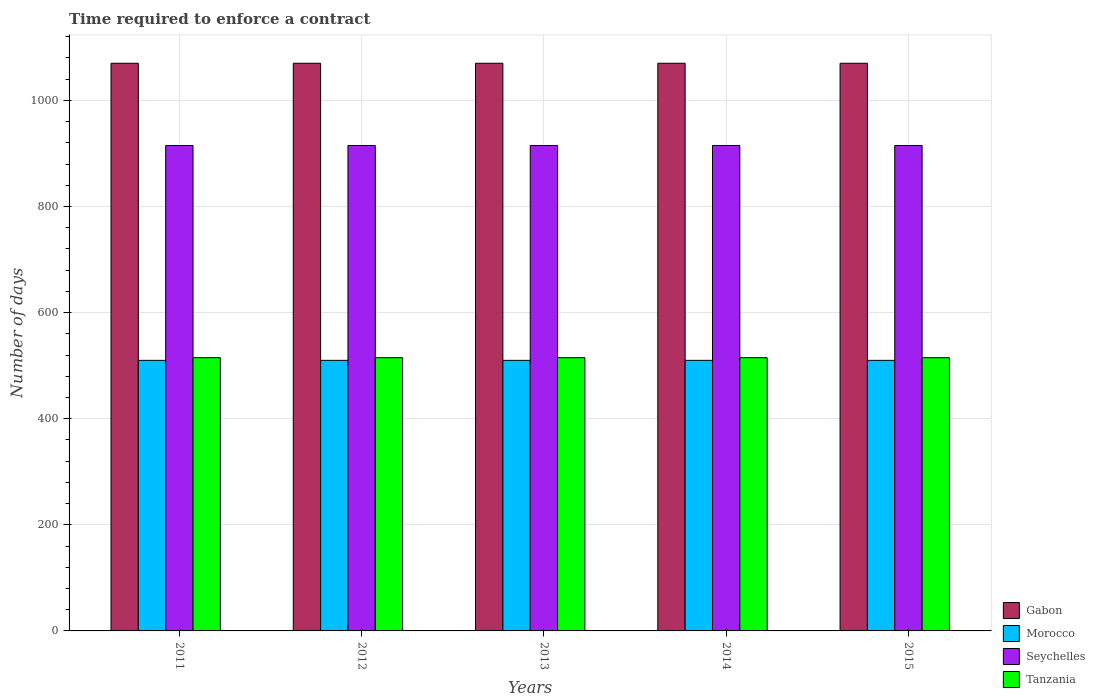How many groups of bars are there?
Make the answer very short. 5. Are the number of bars per tick equal to the number of legend labels?
Provide a succinct answer. Yes. How many bars are there on the 3rd tick from the left?
Ensure brevity in your answer.  4. How many bars are there on the 5th tick from the right?
Ensure brevity in your answer.  4. What is the label of the 1st group of bars from the left?
Your answer should be very brief. 2011. What is the number of days required to enforce a contract in Tanzania in 2013?
Give a very brief answer. 515. Across all years, what is the maximum number of days required to enforce a contract in Morocco?
Make the answer very short. 510. Across all years, what is the minimum number of days required to enforce a contract in Tanzania?
Offer a terse response. 515. In which year was the number of days required to enforce a contract in Morocco maximum?
Your response must be concise. 2011. In which year was the number of days required to enforce a contract in Seychelles minimum?
Give a very brief answer. 2011. What is the total number of days required to enforce a contract in Gabon in the graph?
Provide a short and direct response. 5350. What is the difference between the number of days required to enforce a contract in Tanzania in 2012 and that in 2013?
Your response must be concise. 0. What is the difference between the number of days required to enforce a contract in Gabon in 2011 and the number of days required to enforce a contract in Morocco in 2014?
Make the answer very short. 560. What is the average number of days required to enforce a contract in Morocco per year?
Make the answer very short. 510. In the year 2014, what is the difference between the number of days required to enforce a contract in Morocco and number of days required to enforce a contract in Tanzania?
Keep it short and to the point. -5. In how many years, is the number of days required to enforce a contract in Morocco greater than 840 days?
Your answer should be compact. 0. Is the number of days required to enforce a contract in Morocco in 2011 less than that in 2014?
Make the answer very short. No. Is the difference between the number of days required to enforce a contract in Morocco in 2011 and 2012 greater than the difference between the number of days required to enforce a contract in Tanzania in 2011 and 2012?
Keep it short and to the point. No. In how many years, is the number of days required to enforce a contract in Seychelles greater than the average number of days required to enforce a contract in Seychelles taken over all years?
Your answer should be compact. 0. Is the sum of the number of days required to enforce a contract in Tanzania in 2011 and 2013 greater than the maximum number of days required to enforce a contract in Seychelles across all years?
Make the answer very short. Yes. What does the 4th bar from the left in 2015 represents?
Provide a succinct answer. Tanzania. What does the 4th bar from the right in 2011 represents?
Make the answer very short. Gabon. Is it the case that in every year, the sum of the number of days required to enforce a contract in Morocco and number of days required to enforce a contract in Seychelles is greater than the number of days required to enforce a contract in Gabon?
Provide a short and direct response. Yes. How many bars are there?
Keep it short and to the point. 20. Are all the bars in the graph horizontal?
Your response must be concise. No. How many years are there in the graph?
Keep it short and to the point. 5. What is the difference between two consecutive major ticks on the Y-axis?
Your response must be concise. 200. Are the values on the major ticks of Y-axis written in scientific E-notation?
Your answer should be very brief. No. Does the graph contain grids?
Offer a very short reply. Yes. Where does the legend appear in the graph?
Provide a succinct answer. Bottom right. How are the legend labels stacked?
Offer a very short reply. Vertical. What is the title of the graph?
Keep it short and to the point. Time required to enforce a contract. Does "European Union" appear as one of the legend labels in the graph?
Ensure brevity in your answer.  No. What is the label or title of the Y-axis?
Your answer should be very brief. Number of days. What is the Number of days in Gabon in 2011?
Provide a succinct answer. 1070. What is the Number of days of Morocco in 2011?
Make the answer very short. 510. What is the Number of days of Seychelles in 2011?
Give a very brief answer. 915. What is the Number of days of Tanzania in 2011?
Your answer should be very brief. 515. What is the Number of days of Gabon in 2012?
Your answer should be compact. 1070. What is the Number of days of Morocco in 2012?
Make the answer very short. 510. What is the Number of days in Seychelles in 2012?
Keep it short and to the point. 915. What is the Number of days in Tanzania in 2012?
Your answer should be compact. 515. What is the Number of days of Gabon in 2013?
Offer a very short reply. 1070. What is the Number of days in Morocco in 2013?
Give a very brief answer. 510. What is the Number of days of Seychelles in 2013?
Keep it short and to the point. 915. What is the Number of days of Tanzania in 2013?
Ensure brevity in your answer.  515. What is the Number of days of Gabon in 2014?
Keep it short and to the point. 1070. What is the Number of days of Morocco in 2014?
Make the answer very short. 510. What is the Number of days in Seychelles in 2014?
Make the answer very short. 915. What is the Number of days in Tanzania in 2014?
Offer a terse response. 515. What is the Number of days of Gabon in 2015?
Provide a short and direct response. 1070. What is the Number of days of Morocco in 2015?
Offer a very short reply. 510. What is the Number of days of Seychelles in 2015?
Provide a succinct answer. 915. What is the Number of days of Tanzania in 2015?
Your response must be concise. 515. Across all years, what is the maximum Number of days in Gabon?
Keep it short and to the point. 1070. Across all years, what is the maximum Number of days of Morocco?
Provide a succinct answer. 510. Across all years, what is the maximum Number of days in Seychelles?
Your answer should be compact. 915. Across all years, what is the maximum Number of days in Tanzania?
Offer a terse response. 515. Across all years, what is the minimum Number of days in Gabon?
Provide a succinct answer. 1070. Across all years, what is the minimum Number of days of Morocco?
Offer a very short reply. 510. Across all years, what is the minimum Number of days in Seychelles?
Your answer should be very brief. 915. Across all years, what is the minimum Number of days of Tanzania?
Give a very brief answer. 515. What is the total Number of days of Gabon in the graph?
Keep it short and to the point. 5350. What is the total Number of days in Morocco in the graph?
Give a very brief answer. 2550. What is the total Number of days in Seychelles in the graph?
Provide a succinct answer. 4575. What is the total Number of days of Tanzania in the graph?
Offer a very short reply. 2575. What is the difference between the Number of days of Gabon in 2011 and that in 2012?
Keep it short and to the point. 0. What is the difference between the Number of days of Seychelles in 2011 and that in 2012?
Your answer should be compact. 0. What is the difference between the Number of days in Gabon in 2011 and that in 2013?
Provide a short and direct response. 0. What is the difference between the Number of days in Morocco in 2011 and that in 2013?
Your response must be concise. 0. What is the difference between the Number of days in Gabon in 2011 and that in 2014?
Your response must be concise. 0. What is the difference between the Number of days in Gabon in 2011 and that in 2015?
Provide a succinct answer. 0. What is the difference between the Number of days in Morocco in 2011 and that in 2015?
Your answer should be very brief. 0. What is the difference between the Number of days of Morocco in 2012 and that in 2013?
Make the answer very short. 0. What is the difference between the Number of days of Seychelles in 2012 and that in 2013?
Keep it short and to the point. 0. What is the difference between the Number of days of Seychelles in 2012 and that in 2014?
Ensure brevity in your answer.  0. What is the difference between the Number of days of Tanzania in 2012 and that in 2014?
Your answer should be very brief. 0. What is the difference between the Number of days of Tanzania in 2012 and that in 2015?
Provide a short and direct response. 0. What is the difference between the Number of days in Gabon in 2013 and that in 2014?
Your response must be concise. 0. What is the difference between the Number of days of Tanzania in 2013 and that in 2014?
Your response must be concise. 0. What is the difference between the Number of days of Gabon in 2013 and that in 2015?
Make the answer very short. 0. What is the difference between the Number of days of Morocco in 2013 and that in 2015?
Make the answer very short. 0. What is the difference between the Number of days in Seychelles in 2013 and that in 2015?
Ensure brevity in your answer.  0. What is the difference between the Number of days in Gabon in 2014 and that in 2015?
Provide a succinct answer. 0. What is the difference between the Number of days of Morocco in 2014 and that in 2015?
Your answer should be very brief. 0. What is the difference between the Number of days in Seychelles in 2014 and that in 2015?
Provide a short and direct response. 0. What is the difference between the Number of days of Tanzania in 2014 and that in 2015?
Offer a very short reply. 0. What is the difference between the Number of days of Gabon in 2011 and the Number of days of Morocco in 2012?
Offer a terse response. 560. What is the difference between the Number of days of Gabon in 2011 and the Number of days of Seychelles in 2012?
Give a very brief answer. 155. What is the difference between the Number of days in Gabon in 2011 and the Number of days in Tanzania in 2012?
Provide a short and direct response. 555. What is the difference between the Number of days of Morocco in 2011 and the Number of days of Seychelles in 2012?
Make the answer very short. -405. What is the difference between the Number of days in Gabon in 2011 and the Number of days in Morocco in 2013?
Provide a short and direct response. 560. What is the difference between the Number of days of Gabon in 2011 and the Number of days of Seychelles in 2013?
Make the answer very short. 155. What is the difference between the Number of days in Gabon in 2011 and the Number of days in Tanzania in 2013?
Ensure brevity in your answer.  555. What is the difference between the Number of days of Morocco in 2011 and the Number of days of Seychelles in 2013?
Give a very brief answer. -405. What is the difference between the Number of days in Gabon in 2011 and the Number of days in Morocco in 2014?
Provide a succinct answer. 560. What is the difference between the Number of days of Gabon in 2011 and the Number of days of Seychelles in 2014?
Your answer should be very brief. 155. What is the difference between the Number of days in Gabon in 2011 and the Number of days in Tanzania in 2014?
Provide a succinct answer. 555. What is the difference between the Number of days in Morocco in 2011 and the Number of days in Seychelles in 2014?
Provide a succinct answer. -405. What is the difference between the Number of days in Gabon in 2011 and the Number of days in Morocco in 2015?
Your answer should be compact. 560. What is the difference between the Number of days of Gabon in 2011 and the Number of days of Seychelles in 2015?
Offer a very short reply. 155. What is the difference between the Number of days in Gabon in 2011 and the Number of days in Tanzania in 2015?
Give a very brief answer. 555. What is the difference between the Number of days of Morocco in 2011 and the Number of days of Seychelles in 2015?
Your answer should be very brief. -405. What is the difference between the Number of days in Gabon in 2012 and the Number of days in Morocco in 2013?
Make the answer very short. 560. What is the difference between the Number of days in Gabon in 2012 and the Number of days in Seychelles in 2013?
Provide a short and direct response. 155. What is the difference between the Number of days of Gabon in 2012 and the Number of days of Tanzania in 2013?
Give a very brief answer. 555. What is the difference between the Number of days of Morocco in 2012 and the Number of days of Seychelles in 2013?
Provide a succinct answer. -405. What is the difference between the Number of days in Seychelles in 2012 and the Number of days in Tanzania in 2013?
Keep it short and to the point. 400. What is the difference between the Number of days of Gabon in 2012 and the Number of days of Morocco in 2014?
Provide a short and direct response. 560. What is the difference between the Number of days of Gabon in 2012 and the Number of days of Seychelles in 2014?
Offer a very short reply. 155. What is the difference between the Number of days of Gabon in 2012 and the Number of days of Tanzania in 2014?
Give a very brief answer. 555. What is the difference between the Number of days in Morocco in 2012 and the Number of days in Seychelles in 2014?
Provide a succinct answer. -405. What is the difference between the Number of days of Morocco in 2012 and the Number of days of Tanzania in 2014?
Provide a succinct answer. -5. What is the difference between the Number of days of Gabon in 2012 and the Number of days of Morocco in 2015?
Your response must be concise. 560. What is the difference between the Number of days of Gabon in 2012 and the Number of days of Seychelles in 2015?
Offer a very short reply. 155. What is the difference between the Number of days in Gabon in 2012 and the Number of days in Tanzania in 2015?
Give a very brief answer. 555. What is the difference between the Number of days in Morocco in 2012 and the Number of days in Seychelles in 2015?
Your response must be concise. -405. What is the difference between the Number of days in Morocco in 2012 and the Number of days in Tanzania in 2015?
Provide a succinct answer. -5. What is the difference between the Number of days of Seychelles in 2012 and the Number of days of Tanzania in 2015?
Provide a succinct answer. 400. What is the difference between the Number of days of Gabon in 2013 and the Number of days of Morocco in 2014?
Ensure brevity in your answer.  560. What is the difference between the Number of days in Gabon in 2013 and the Number of days in Seychelles in 2014?
Your answer should be very brief. 155. What is the difference between the Number of days of Gabon in 2013 and the Number of days of Tanzania in 2014?
Ensure brevity in your answer.  555. What is the difference between the Number of days of Morocco in 2013 and the Number of days of Seychelles in 2014?
Keep it short and to the point. -405. What is the difference between the Number of days of Morocco in 2013 and the Number of days of Tanzania in 2014?
Your answer should be compact. -5. What is the difference between the Number of days of Gabon in 2013 and the Number of days of Morocco in 2015?
Keep it short and to the point. 560. What is the difference between the Number of days of Gabon in 2013 and the Number of days of Seychelles in 2015?
Ensure brevity in your answer.  155. What is the difference between the Number of days of Gabon in 2013 and the Number of days of Tanzania in 2015?
Provide a short and direct response. 555. What is the difference between the Number of days in Morocco in 2013 and the Number of days in Seychelles in 2015?
Give a very brief answer. -405. What is the difference between the Number of days in Seychelles in 2013 and the Number of days in Tanzania in 2015?
Your answer should be compact. 400. What is the difference between the Number of days in Gabon in 2014 and the Number of days in Morocco in 2015?
Offer a terse response. 560. What is the difference between the Number of days in Gabon in 2014 and the Number of days in Seychelles in 2015?
Provide a succinct answer. 155. What is the difference between the Number of days in Gabon in 2014 and the Number of days in Tanzania in 2015?
Your response must be concise. 555. What is the difference between the Number of days in Morocco in 2014 and the Number of days in Seychelles in 2015?
Provide a succinct answer. -405. What is the difference between the Number of days of Seychelles in 2014 and the Number of days of Tanzania in 2015?
Your answer should be compact. 400. What is the average Number of days in Gabon per year?
Your answer should be very brief. 1070. What is the average Number of days of Morocco per year?
Your response must be concise. 510. What is the average Number of days in Seychelles per year?
Offer a very short reply. 915. What is the average Number of days in Tanzania per year?
Make the answer very short. 515. In the year 2011, what is the difference between the Number of days in Gabon and Number of days in Morocco?
Keep it short and to the point. 560. In the year 2011, what is the difference between the Number of days in Gabon and Number of days in Seychelles?
Provide a succinct answer. 155. In the year 2011, what is the difference between the Number of days in Gabon and Number of days in Tanzania?
Your response must be concise. 555. In the year 2011, what is the difference between the Number of days of Morocco and Number of days of Seychelles?
Provide a succinct answer. -405. In the year 2011, what is the difference between the Number of days in Morocco and Number of days in Tanzania?
Keep it short and to the point. -5. In the year 2011, what is the difference between the Number of days of Seychelles and Number of days of Tanzania?
Provide a succinct answer. 400. In the year 2012, what is the difference between the Number of days of Gabon and Number of days of Morocco?
Offer a terse response. 560. In the year 2012, what is the difference between the Number of days in Gabon and Number of days in Seychelles?
Make the answer very short. 155. In the year 2012, what is the difference between the Number of days in Gabon and Number of days in Tanzania?
Keep it short and to the point. 555. In the year 2012, what is the difference between the Number of days in Morocco and Number of days in Seychelles?
Ensure brevity in your answer.  -405. In the year 2012, what is the difference between the Number of days in Seychelles and Number of days in Tanzania?
Your answer should be very brief. 400. In the year 2013, what is the difference between the Number of days of Gabon and Number of days of Morocco?
Provide a short and direct response. 560. In the year 2013, what is the difference between the Number of days of Gabon and Number of days of Seychelles?
Keep it short and to the point. 155. In the year 2013, what is the difference between the Number of days in Gabon and Number of days in Tanzania?
Make the answer very short. 555. In the year 2013, what is the difference between the Number of days of Morocco and Number of days of Seychelles?
Give a very brief answer. -405. In the year 2014, what is the difference between the Number of days in Gabon and Number of days in Morocco?
Your response must be concise. 560. In the year 2014, what is the difference between the Number of days of Gabon and Number of days of Seychelles?
Your answer should be compact. 155. In the year 2014, what is the difference between the Number of days of Gabon and Number of days of Tanzania?
Offer a terse response. 555. In the year 2014, what is the difference between the Number of days in Morocco and Number of days in Seychelles?
Your response must be concise. -405. In the year 2015, what is the difference between the Number of days of Gabon and Number of days of Morocco?
Provide a short and direct response. 560. In the year 2015, what is the difference between the Number of days in Gabon and Number of days in Seychelles?
Make the answer very short. 155. In the year 2015, what is the difference between the Number of days in Gabon and Number of days in Tanzania?
Your answer should be compact. 555. In the year 2015, what is the difference between the Number of days of Morocco and Number of days of Seychelles?
Make the answer very short. -405. In the year 2015, what is the difference between the Number of days of Morocco and Number of days of Tanzania?
Offer a terse response. -5. What is the ratio of the Number of days of Morocco in 2011 to that in 2012?
Provide a short and direct response. 1. What is the ratio of the Number of days of Seychelles in 2011 to that in 2012?
Your answer should be compact. 1. What is the ratio of the Number of days in Tanzania in 2011 to that in 2012?
Make the answer very short. 1. What is the ratio of the Number of days in Gabon in 2011 to that in 2014?
Your answer should be very brief. 1. What is the ratio of the Number of days in Seychelles in 2011 to that in 2014?
Provide a succinct answer. 1. What is the ratio of the Number of days in Tanzania in 2011 to that in 2014?
Your response must be concise. 1. What is the ratio of the Number of days of Gabon in 2011 to that in 2015?
Offer a very short reply. 1. What is the ratio of the Number of days in Tanzania in 2011 to that in 2015?
Keep it short and to the point. 1. What is the ratio of the Number of days in Morocco in 2012 to that in 2013?
Your response must be concise. 1. What is the ratio of the Number of days in Morocco in 2012 to that in 2014?
Offer a very short reply. 1. What is the ratio of the Number of days in Tanzania in 2012 to that in 2014?
Provide a succinct answer. 1. What is the ratio of the Number of days of Tanzania in 2012 to that in 2015?
Your answer should be very brief. 1. What is the ratio of the Number of days of Gabon in 2013 to that in 2015?
Your response must be concise. 1. What is the ratio of the Number of days of Seychelles in 2013 to that in 2015?
Give a very brief answer. 1. What is the ratio of the Number of days of Seychelles in 2014 to that in 2015?
Ensure brevity in your answer.  1. What is the difference between the highest and the second highest Number of days in Gabon?
Give a very brief answer. 0. What is the difference between the highest and the second highest Number of days of Seychelles?
Provide a short and direct response. 0. What is the difference between the highest and the second highest Number of days in Tanzania?
Your answer should be compact. 0. What is the difference between the highest and the lowest Number of days in Morocco?
Provide a succinct answer. 0. What is the difference between the highest and the lowest Number of days of Seychelles?
Offer a very short reply. 0. 